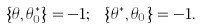<formula> <loc_0><loc_0><loc_500><loc_500>\left \{ \theta , \theta _ { 0 } ^ { \ast } \right \} = - 1 ; \ \left \{ \theta ^ { \ast } , \theta _ { 0 } \right \} = - 1 .</formula> 